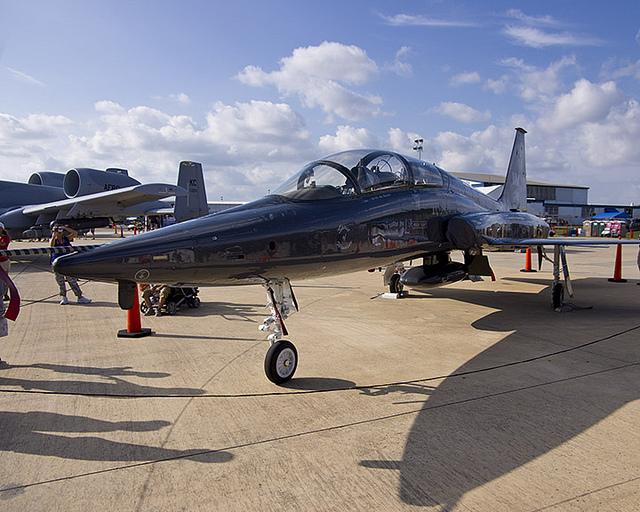Is this a passenger plane?
Short answer required. No. Is there an A-10 Warthog in the photo?
Keep it brief. Yes. What color is the plane?
Quick response, please. Black. What color is the traffic cone?
Be succinct. Orange. What is the number on the blue plane?
Short answer required. 1. Is this an f 16?
Keep it brief. Yes. How many wheels on the plane?
Write a very short answer. 3. Are these historical planes?
Give a very brief answer. Yes. 